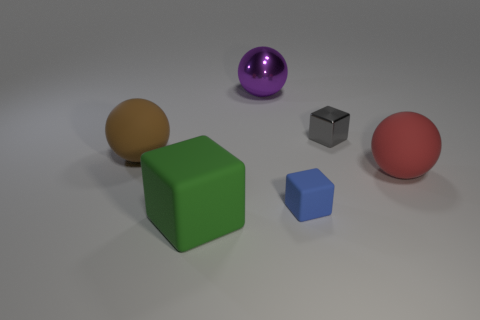Subtract all matte spheres. How many spheres are left? 1 Add 3 red things. How many objects exist? 9 Subtract 1 blocks. How many blocks are left? 2 Subtract all blue balls. Subtract all gray cylinders. How many balls are left? 3 Subtract all purple metallic cylinders. Subtract all blue rubber things. How many objects are left? 5 Add 2 big green matte things. How many big green matte things are left? 3 Add 2 big purple matte cubes. How many big purple matte cubes exist? 2 Subtract 0 red cubes. How many objects are left? 6 